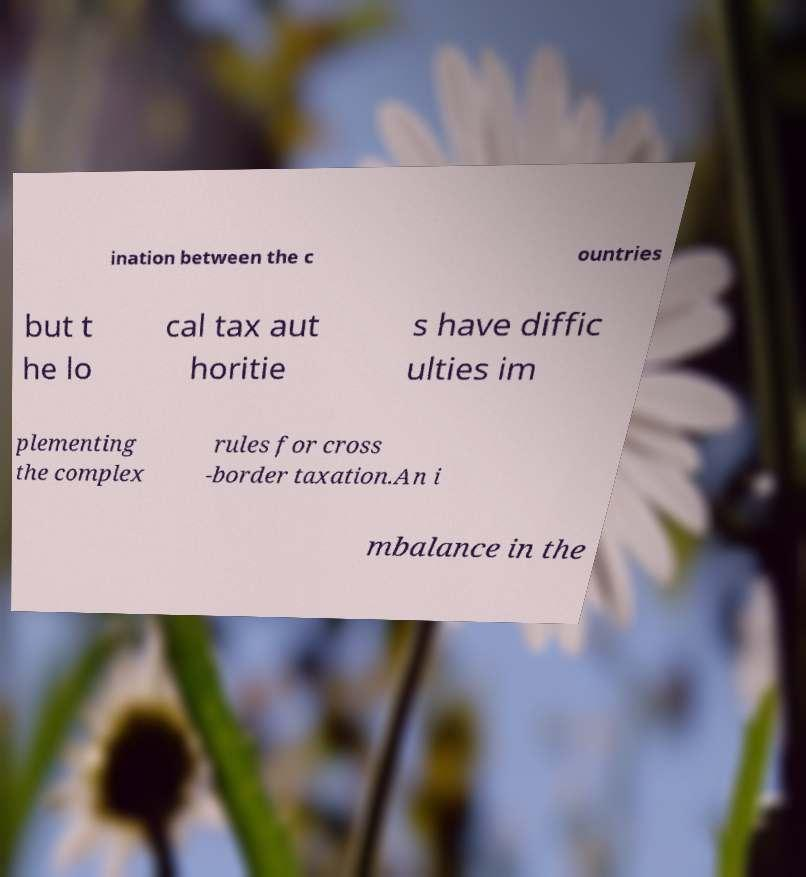Please identify and transcribe the text found in this image. ination between the c ountries but t he lo cal tax aut horitie s have diffic ulties im plementing the complex rules for cross -border taxation.An i mbalance in the 